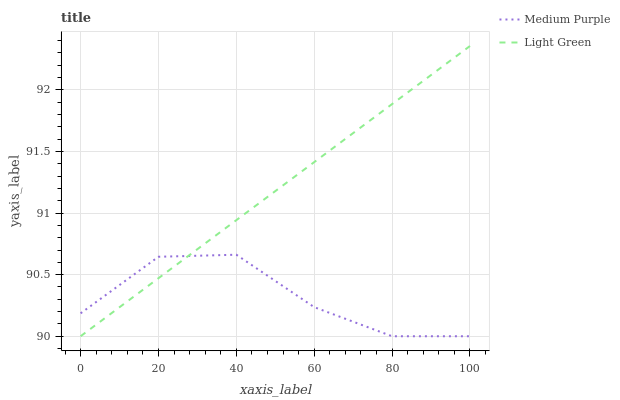Does Medium Purple have the minimum area under the curve?
Answer yes or no. Yes. Does Light Green have the maximum area under the curve?
Answer yes or no. Yes. Does Light Green have the minimum area under the curve?
Answer yes or no. No. Is Light Green the smoothest?
Answer yes or no. Yes. Is Medium Purple the roughest?
Answer yes or no. Yes. Is Light Green the roughest?
Answer yes or no. No. Does Medium Purple have the lowest value?
Answer yes or no. Yes. Does Light Green have the highest value?
Answer yes or no. Yes. Does Light Green intersect Medium Purple?
Answer yes or no. Yes. Is Light Green less than Medium Purple?
Answer yes or no. No. Is Light Green greater than Medium Purple?
Answer yes or no. No. 